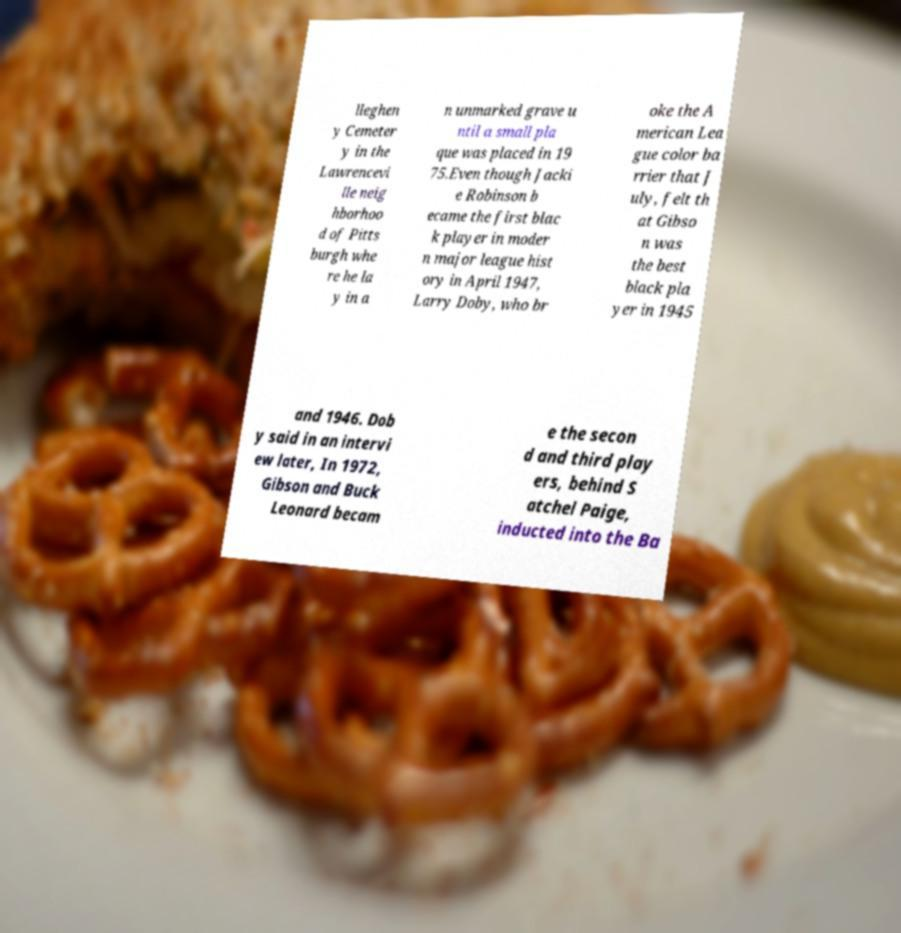What messages or text are displayed in this image? I need them in a readable, typed format. lleghen y Cemeter y in the Lawrencevi lle neig hborhoo d of Pitts burgh whe re he la y in a n unmarked grave u ntil a small pla que was placed in 19 75.Even though Jacki e Robinson b ecame the first blac k player in moder n major league hist ory in April 1947, Larry Doby, who br oke the A merican Lea gue color ba rrier that J uly, felt th at Gibso n was the best black pla yer in 1945 and 1946. Dob y said in an intervi ew later, In 1972, Gibson and Buck Leonard becam e the secon d and third play ers, behind S atchel Paige, inducted into the Ba 